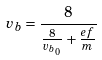Convert formula to latex. <formula><loc_0><loc_0><loc_500><loc_500>v _ { b } = \frac { 8 } { \frac { 8 } { v _ { b _ { 0 } } } + \frac { e f } { m } }</formula> 